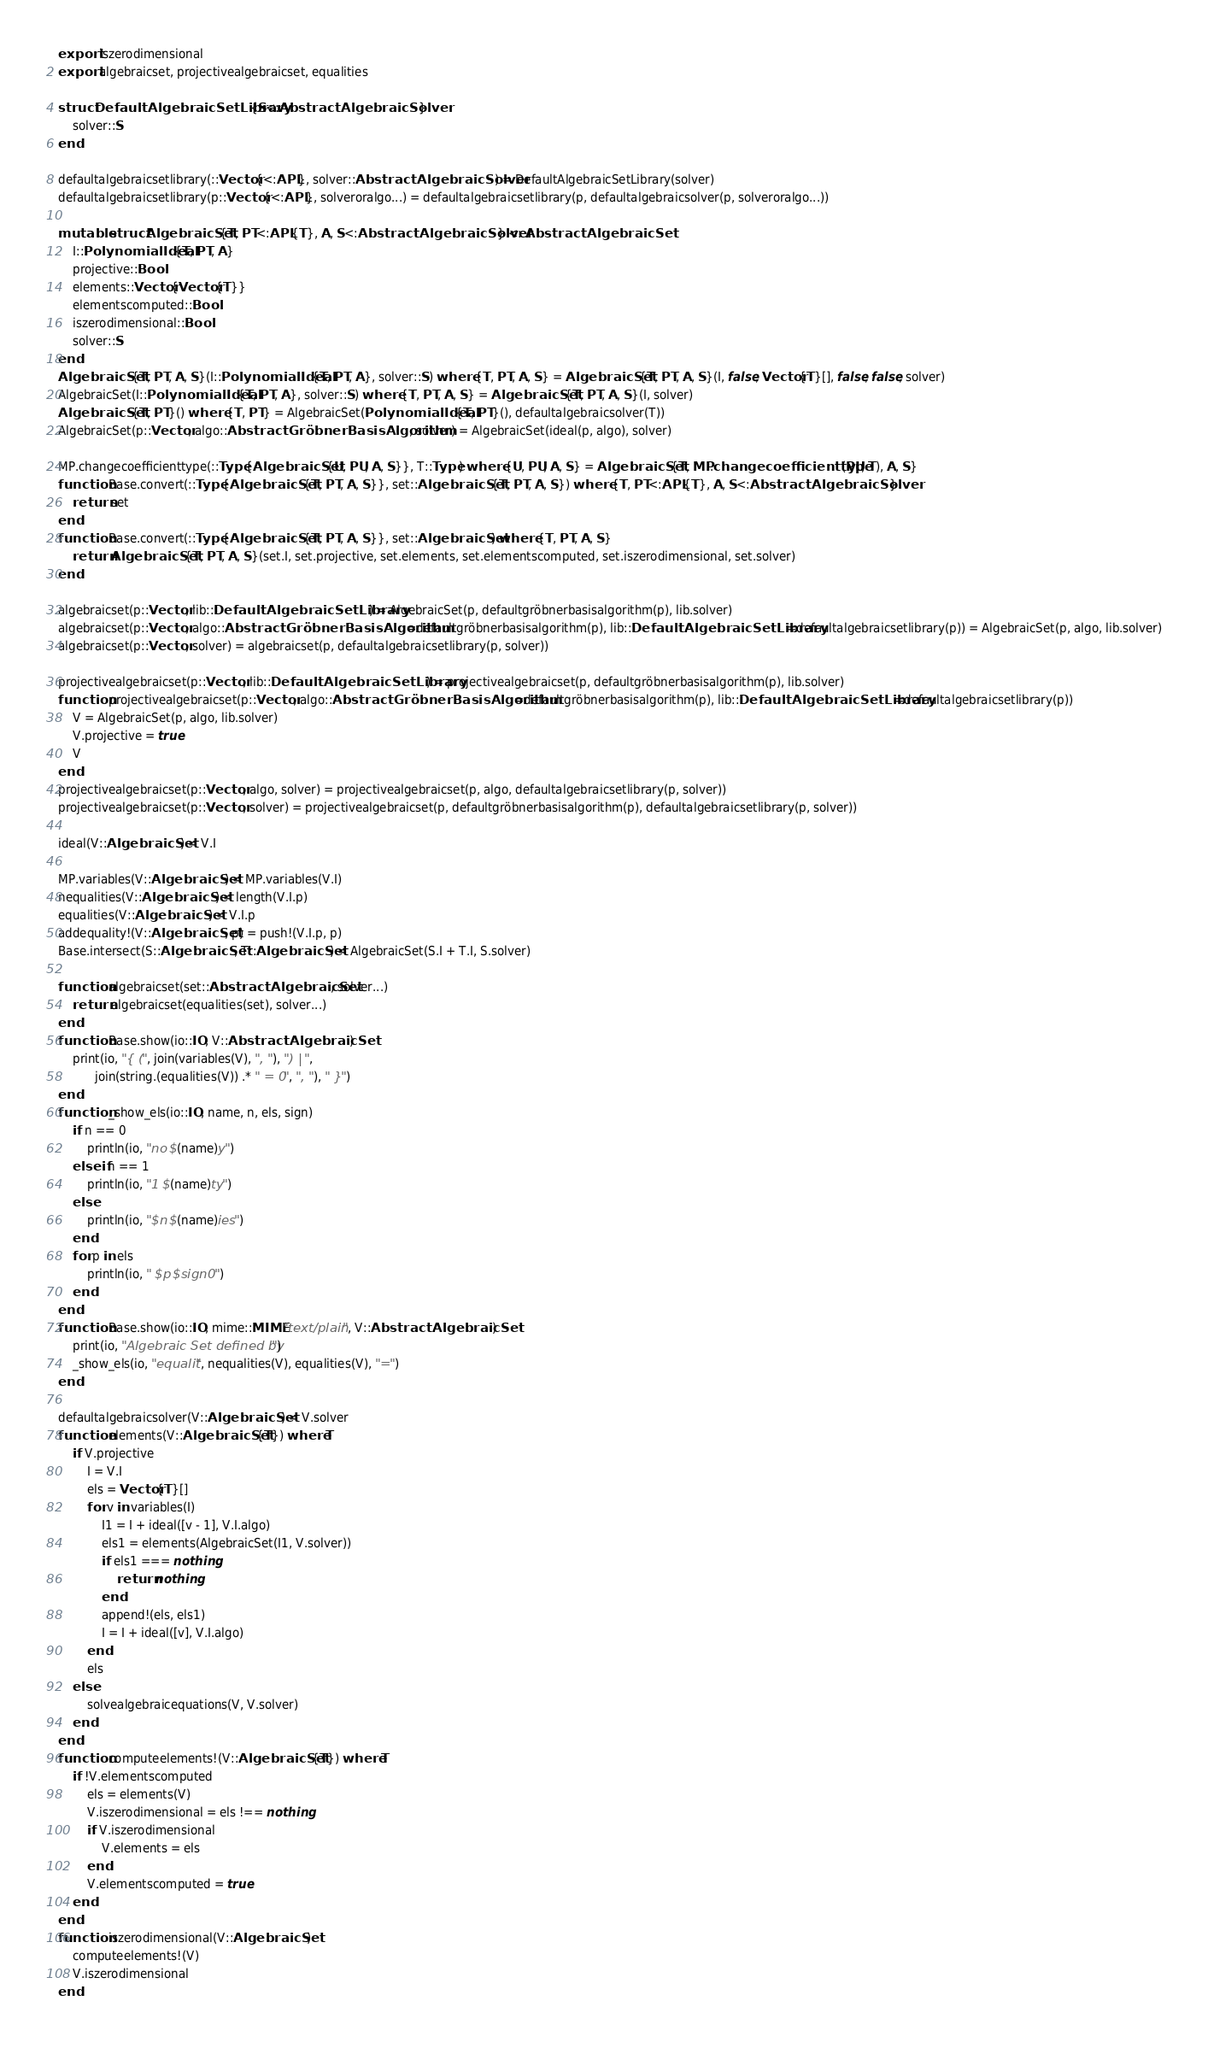<code> <loc_0><loc_0><loc_500><loc_500><_Julia_>export iszerodimensional
export algebraicset, projectivealgebraicset, equalities

struct DefaultAlgebraicSetLibrary{S<:AbstractAlgebraicSolver}
    solver::S
end

defaultalgebraicsetlibrary(::Vector{<:APL}, solver::AbstractAlgebraicSolver) = DefaultAlgebraicSetLibrary(solver)
defaultalgebraicsetlibrary(p::Vector{<:APL}, solveroralgo...) = defaultalgebraicsetlibrary(p, defaultalgebraicsolver(p, solveroralgo...))

mutable struct AlgebraicSet{T, PT<:APL{T}, A, S<:AbstractAlgebraicSolver} <: AbstractAlgebraicSet
    I::PolynomialIdeal{T, PT, A}
    projective::Bool
    elements::Vector{Vector{T}}
    elementscomputed::Bool
    iszerodimensional::Bool
    solver::S
end
AlgebraicSet{T, PT, A, S}(I::PolynomialIdeal{T, PT, A}, solver::S) where {T, PT, A, S} = AlgebraicSet{T, PT, A, S}(I, false, Vector{T}[], false, false, solver)
AlgebraicSet(I::PolynomialIdeal{T, PT, A}, solver::S) where {T, PT, A, S} = AlgebraicSet{T, PT, A, S}(I, solver)
AlgebraicSet{T, PT}() where {T, PT} = AlgebraicSet(PolynomialIdeal{T, PT}(), defaultalgebraicsolver(T))
AlgebraicSet(p::Vector, algo::AbstractGröbnerBasisAlgorithm, solver) = AlgebraicSet(ideal(p, algo), solver)

MP.changecoefficienttype(::Type{AlgebraicSet{U, PU, A, S}}, T::Type) where {U, PU, A, S} = AlgebraicSet{T, MP.changecoefficienttype(PU, T), A, S}
function Base.convert(::Type{AlgebraicSet{T, PT, A, S}}, set::AlgebraicSet{T, PT, A, S}) where {T, PT<:APL{T}, A, S<:AbstractAlgebraicSolver}
    return set
end
function Base.convert(::Type{AlgebraicSet{T, PT, A, S}}, set::AlgebraicSet) where {T, PT, A, S}
    return AlgebraicSet{T, PT, A, S}(set.I, set.projective, set.elements, set.elementscomputed, set.iszerodimensional, set.solver)
end

algebraicset(p::Vector, lib::DefaultAlgebraicSetLibrary) = AlgebraicSet(p, defaultgröbnerbasisalgorithm(p), lib.solver)
algebraicset(p::Vector, algo::AbstractGröbnerBasisAlgorithm=defaultgröbnerbasisalgorithm(p), lib::DefaultAlgebraicSetLibrary=defaultalgebraicsetlibrary(p)) = AlgebraicSet(p, algo, lib.solver)
algebraicset(p::Vector, solver) = algebraicset(p, defaultalgebraicsetlibrary(p, solver))

projectivealgebraicset(p::Vector, lib::DefaultAlgebraicSetLibrary) = projectivealgebraicset(p, defaultgröbnerbasisalgorithm(p), lib.solver)
function projectivealgebraicset(p::Vector, algo::AbstractGröbnerBasisAlgorithm=defaultgröbnerbasisalgorithm(p), lib::DefaultAlgebraicSetLibrary=defaultalgebraicsetlibrary(p))
    V = AlgebraicSet(p, algo, lib.solver)
    V.projective = true
    V
end
projectivealgebraicset(p::Vector, algo, solver) = projectivealgebraicset(p, algo, defaultalgebraicsetlibrary(p, solver))
projectivealgebraicset(p::Vector, solver) = projectivealgebraicset(p, defaultgröbnerbasisalgorithm(p), defaultalgebraicsetlibrary(p, solver))

ideal(V::AlgebraicSet) = V.I

MP.variables(V::AlgebraicSet) = MP.variables(V.I)
nequalities(V::AlgebraicSet) = length(V.I.p)
equalities(V::AlgebraicSet) = V.I.p
addequality!(V::AlgebraicSet, p) = push!(V.I.p, p)
Base.intersect(S::AlgebraicSet, T::AlgebraicSet) = AlgebraicSet(S.I + T.I, S.solver)

function algebraicset(set::AbstractAlgebraicSet, solver...)
    return algebraicset(equalities(set), solver...)
end
function Base.show(io::IO, V::AbstractAlgebraicSet)
    print(io, "{ (", join(variables(V), ", "), ") | ",
          join(string.(equalities(V)) .* " = 0", ", "), " }")
end
function _show_els(io::IO, name, n, els, sign)
    if n == 0
        println(io, "no $(name)y")
    elseif n == 1
        println(io, "1 $(name)ty")
    else
        println(io, "$n $(name)ies")
    end
    for p in els
        println(io, " $p $sign 0")
    end
end
function Base.show(io::IO, mime::MIME"text/plain", V::AbstractAlgebraicSet)
    print(io, "Algebraic Set defined by ")
    _show_els(io, "equalit", nequalities(V), equalities(V), "=")
end

defaultalgebraicsolver(V::AlgebraicSet) = V.solver
function elements(V::AlgebraicSet{T}) where T
    if V.projective
        I = V.I
        els = Vector{T}[]
        for v in variables(I)
            I1 = I + ideal([v - 1], V.I.algo)
            els1 = elements(AlgebraicSet(I1, V.solver))
            if els1 === nothing
                return nothing
            end
            append!(els, els1)
            I = I + ideal([v], V.I.algo)
        end
        els
    else
        solvealgebraicequations(V, V.solver)
    end
end
function computeelements!(V::AlgebraicSet{T}) where T
    if !V.elementscomputed
        els = elements(V)
        V.iszerodimensional = els !== nothing
        if V.iszerodimensional
            V.elements = els
        end
        V.elementscomputed = true
    end
end
function iszerodimensional(V::AlgebraicSet)
    computeelements!(V)
    V.iszerodimensional
end
</code> 